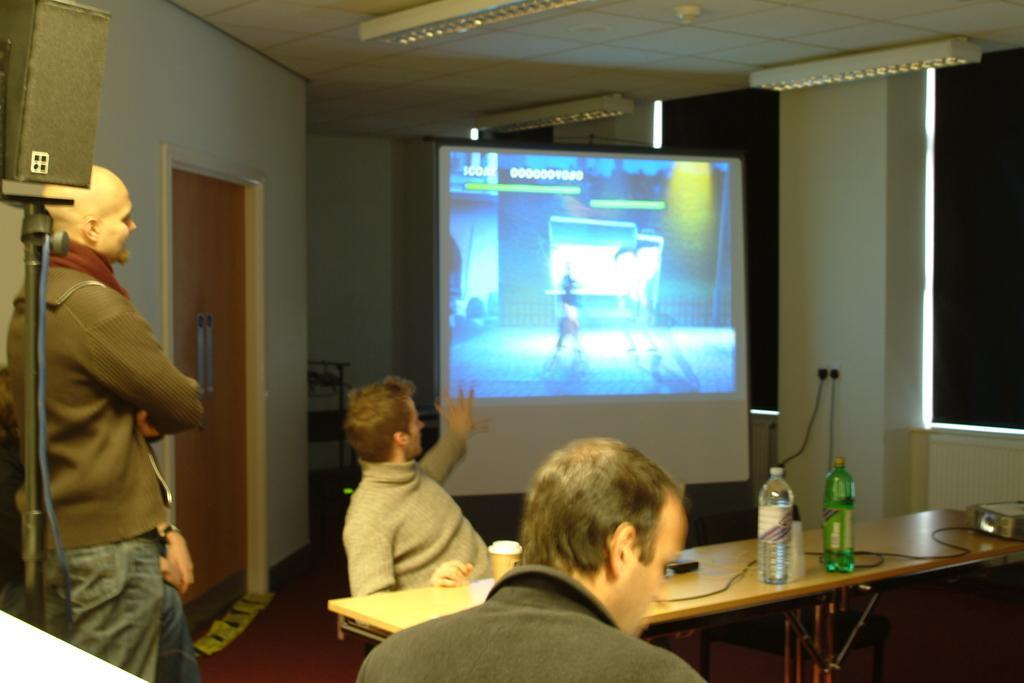In one or two sentences, can you explain what this image depicts? At the top we can see the ceiling and the lights. In this picture we can see a projector screen. We can see a man is standing near to a door. On the left side we can see a speaker on a stand. We can see men near to a a table and on the table we can see bottles, projector device and few objects. On the right side of the picture we can see the window blind. Far we can see a black object on the floor beside to a screen. 